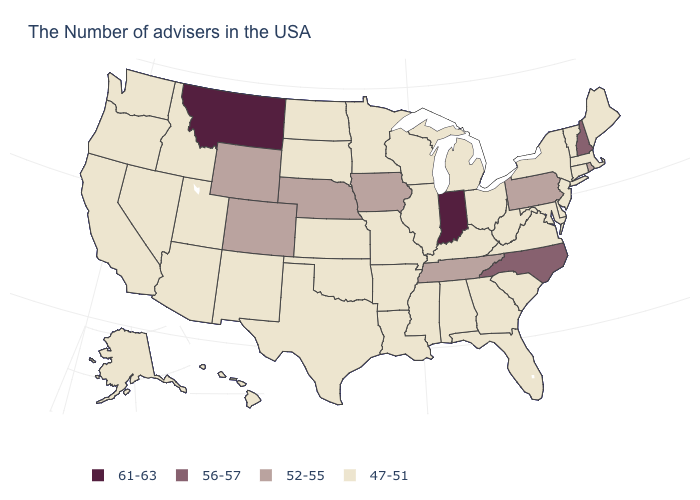Name the states that have a value in the range 56-57?
Answer briefly. New Hampshire, North Carolina. What is the value of Maine?
Write a very short answer. 47-51. What is the value of Alaska?
Write a very short answer. 47-51. What is the highest value in the USA?
Concise answer only. 61-63. Does Idaho have a higher value than Montana?
Give a very brief answer. No. What is the value of New York?
Keep it brief. 47-51. Name the states that have a value in the range 56-57?
Be succinct. New Hampshire, North Carolina. What is the highest value in states that border Oregon?
Give a very brief answer. 47-51. What is the highest value in the USA?
Keep it brief. 61-63. Does Indiana have the highest value in the USA?
Write a very short answer. Yes. What is the value of Arizona?
Answer briefly. 47-51. What is the lowest value in states that border New Jersey?
Be succinct. 47-51. Name the states that have a value in the range 47-51?
Write a very short answer. Maine, Massachusetts, Vermont, Connecticut, New York, New Jersey, Delaware, Maryland, Virginia, South Carolina, West Virginia, Ohio, Florida, Georgia, Michigan, Kentucky, Alabama, Wisconsin, Illinois, Mississippi, Louisiana, Missouri, Arkansas, Minnesota, Kansas, Oklahoma, Texas, South Dakota, North Dakota, New Mexico, Utah, Arizona, Idaho, Nevada, California, Washington, Oregon, Alaska, Hawaii. Name the states that have a value in the range 52-55?
Write a very short answer. Rhode Island, Pennsylvania, Tennessee, Iowa, Nebraska, Wyoming, Colorado. What is the highest value in the MidWest ?
Be succinct. 61-63. 